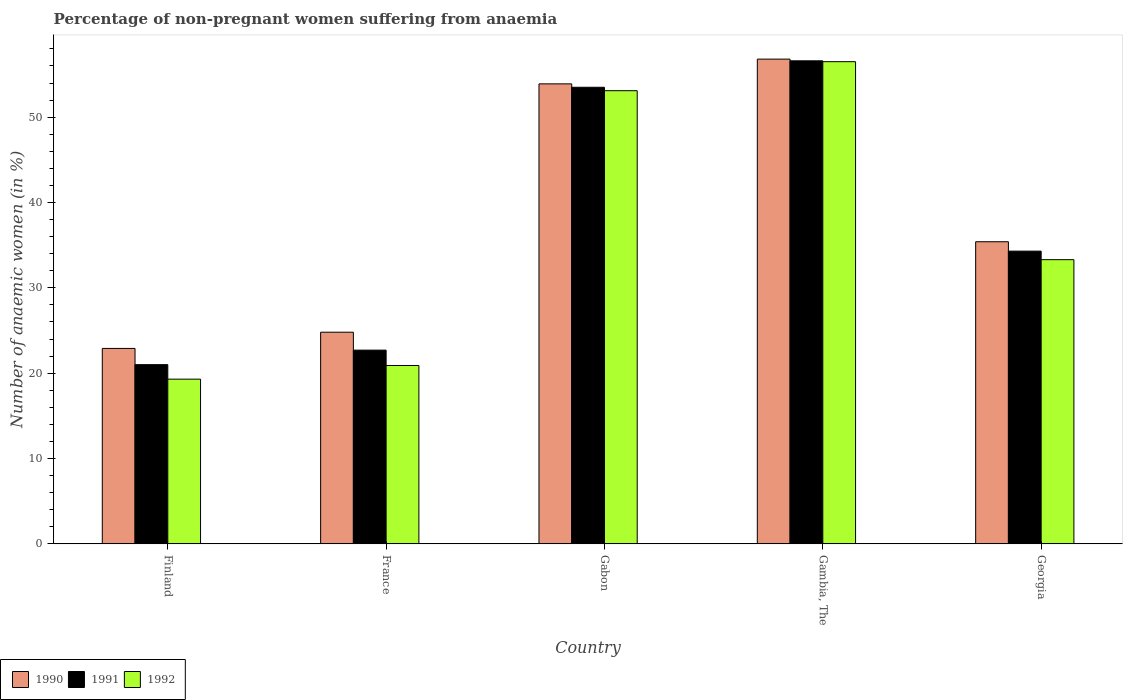How many different coloured bars are there?
Make the answer very short. 3. What is the label of the 3rd group of bars from the left?
Give a very brief answer. Gabon. What is the percentage of non-pregnant women suffering from anaemia in 1991 in Gabon?
Your answer should be compact. 53.5. Across all countries, what is the maximum percentage of non-pregnant women suffering from anaemia in 1990?
Your answer should be very brief. 56.8. Across all countries, what is the minimum percentage of non-pregnant women suffering from anaemia in 1992?
Offer a terse response. 19.3. In which country was the percentage of non-pregnant women suffering from anaemia in 1992 maximum?
Provide a succinct answer. Gambia, The. In which country was the percentage of non-pregnant women suffering from anaemia in 1992 minimum?
Ensure brevity in your answer.  Finland. What is the total percentage of non-pregnant women suffering from anaemia in 1991 in the graph?
Your answer should be very brief. 188.1. What is the difference between the percentage of non-pregnant women suffering from anaemia in 1991 in Finland and that in France?
Provide a succinct answer. -1.7. What is the difference between the percentage of non-pregnant women suffering from anaemia in 1991 in Georgia and the percentage of non-pregnant women suffering from anaemia in 1992 in Gabon?
Offer a terse response. -18.8. What is the average percentage of non-pregnant women suffering from anaemia in 1992 per country?
Provide a short and direct response. 36.62. What is the difference between the percentage of non-pregnant women suffering from anaemia of/in 1990 and percentage of non-pregnant women suffering from anaemia of/in 1992 in Finland?
Offer a terse response. 3.6. In how many countries, is the percentage of non-pregnant women suffering from anaemia in 1992 greater than 12 %?
Give a very brief answer. 5. What is the ratio of the percentage of non-pregnant women suffering from anaemia in 1992 in Finland to that in France?
Your answer should be very brief. 0.92. Is the percentage of non-pregnant women suffering from anaemia in 1992 in France less than that in Georgia?
Your response must be concise. Yes. Is the difference between the percentage of non-pregnant women suffering from anaemia in 1990 in France and Gambia, The greater than the difference between the percentage of non-pregnant women suffering from anaemia in 1992 in France and Gambia, The?
Give a very brief answer. Yes. What is the difference between the highest and the second highest percentage of non-pregnant women suffering from anaemia in 1991?
Provide a succinct answer. 22.3. What is the difference between the highest and the lowest percentage of non-pregnant women suffering from anaemia in 1992?
Your answer should be very brief. 37.2. In how many countries, is the percentage of non-pregnant women suffering from anaemia in 1992 greater than the average percentage of non-pregnant women suffering from anaemia in 1992 taken over all countries?
Ensure brevity in your answer.  2. What does the 3rd bar from the left in France represents?
Offer a very short reply. 1992. What does the 3rd bar from the right in Gambia, The represents?
Your answer should be compact. 1990. How many countries are there in the graph?
Keep it short and to the point. 5. Does the graph contain any zero values?
Provide a short and direct response. No. Where does the legend appear in the graph?
Offer a terse response. Bottom left. What is the title of the graph?
Give a very brief answer. Percentage of non-pregnant women suffering from anaemia. Does "1974" appear as one of the legend labels in the graph?
Make the answer very short. No. What is the label or title of the Y-axis?
Your answer should be very brief. Number of anaemic women (in %). What is the Number of anaemic women (in %) of 1990 in Finland?
Offer a very short reply. 22.9. What is the Number of anaemic women (in %) of 1991 in Finland?
Your answer should be compact. 21. What is the Number of anaemic women (in %) of 1992 in Finland?
Your answer should be very brief. 19.3. What is the Number of anaemic women (in %) in 1990 in France?
Your answer should be compact. 24.8. What is the Number of anaemic women (in %) of 1991 in France?
Provide a short and direct response. 22.7. What is the Number of anaemic women (in %) of 1992 in France?
Your answer should be very brief. 20.9. What is the Number of anaemic women (in %) in 1990 in Gabon?
Provide a short and direct response. 53.9. What is the Number of anaemic women (in %) of 1991 in Gabon?
Make the answer very short. 53.5. What is the Number of anaemic women (in %) in 1992 in Gabon?
Your response must be concise. 53.1. What is the Number of anaemic women (in %) in 1990 in Gambia, The?
Make the answer very short. 56.8. What is the Number of anaemic women (in %) of 1991 in Gambia, The?
Make the answer very short. 56.6. What is the Number of anaemic women (in %) in 1992 in Gambia, The?
Your answer should be very brief. 56.5. What is the Number of anaemic women (in %) of 1990 in Georgia?
Your answer should be very brief. 35.4. What is the Number of anaemic women (in %) in 1991 in Georgia?
Provide a succinct answer. 34.3. What is the Number of anaemic women (in %) in 1992 in Georgia?
Keep it short and to the point. 33.3. Across all countries, what is the maximum Number of anaemic women (in %) in 1990?
Your answer should be compact. 56.8. Across all countries, what is the maximum Number of anaemic women (in %) in 1991?
Make the answer very short. 56.6. Across all countries, what is the maximum Number of anaemic women (in %) in 1992?
Your answer should be compact. 56.5. Across all countries, what is the minimum Number of anaemic women (in %) in 1990?
Make the answer very short. 22.9. Across all countries, what is the minimum Number of anaemic women (in %) of 1991?
Offer a terse response. 21. Across all countries, what is the minimum Number of anaemic women (in %) in 1992?
Your answer should be compact. 19.3. What is the total Number of anaemic women (in %) in 1990 in the graph?
Your answer should be very brief. 193.8. What is the total Number of anaemic women (in %) of 1991 in the graph?
Your answer should be compact. 188.1. What is the total Number of anaemic women (in %) in 1992 in the graph?
Keep it short and to the point. 183.1. What is the difference between the Number of anaemic women (in %) of 1990 in Finland and that in Gabon?
Make the answer very short. -31. What is the difference between the Number of anaemic women (in %) of 1991 in Finland and that in Gabon?
Give a very brief answer. -32.5. What is the difference between the Number of anaemic women (in %) in 1992 in Finland and that in Gabon?
Your answer should be compact. -33.8. What is the difference between the Number of anaemic women (in %) of 1990 in Finland and that in Gambia, The?
Ensure brevity in your answer.  -33.9. What is the difference between the Number of anaemic women (in %) in 1991 in Finland and that in Gambia, The?
Your response must be concise. -35.6. What is the difference between the Number of anaemic women (in %) in 1992 in Finland and that in Gambia, The?
Your answer should be compact. -37.2. What is the difference between the Number of anaemic women (in %) in 1990 in Finland and that in Georgia?
Give a very brief answer. -12.5. What is the difference between the Number of anaemic women (in %) of 1991 in Finland and that in Georgia?
Your answer should be very brief. -13.3. What is the difference between the Number of anaemic women (in %) of 1992 in Finland and that in Georgia?
Make the answer very short. -14. What is the difference between the Number of anaemic women (in %) of 1990 in France and that in Gabon?
Your answer should be very brief. -29.1. What is the difference between the Number of anaemic women (in %) of 1991 in France and that in Gabon?
Ensure brevity in your answer.  -30.8. What is the difference between the Number of anaemic women (in %) in 1992 in France and that in Gabon?
Make the answer very short. -32.2. What is the difference between the Number of anaemic women (in %) of 1990 in France and that in Gambia, The?
Make the answer very short. -32. What is the difference between the Number of anaemic women (in %) of 1991 in France and that in Gambia, The?
Your response must be concise. -33.9. What is the difference between the Number of anaemic women (in %) in 1992 in France and that in Gambia, The?
Offer a very short reply. -35.6. What is the difference between the Number of anaemic women (in %) of 1990 in France and that in Georgia?
Your answer should be compact. -10.6. What is the difference between the Number of anaemic women (in %) in 1992 in France and that in Georgia?
Your answer should be very brief. -12.4. What is the difference between the Number of anaemic women (in %) in 1990 in Gabon and that in Gambia, The?
Make the answer very short. -2.9. What is the difference between the Number of anaemic women (in %) in 1990 in Gabon and that in Georgia?
Keep it short and to the point. 18.5. What is the difference between the Number of anaemic women (in %) of 1991 in Gabon and that in Georgia?
Make the answer very short. 19.2. What is the difference between the Number of anaemic women (in %) in 1992 in Gabon and that in Georgia?
Provide a succinct answer. 19.8. What is the difference between the Number of anaemic women (in %) in 1990 in Gambia, The and that in Georgia?
Offer a very short reply. 21.4. What is the difference between the Number of anaemic women (in %) in 1991 in Gambia, The and that in Georgia?
Your answer should be compact. 22.3. What is the difference between the Number of anaemic women (in %) of 1992 in Gambia, The and that in Georgia?
Offer a terse response. 23.2. What is the difference between the Number of anaemic women (in %) of 1990 in Finland and the Number of anaemic women (in %) of 1991 in France?
Your response must be concise. 0.2. What is the difference between the Number of anaemic women (in %) in 1990 in Finland and the Number of anaemic women (in %) in 1991 in Gabon?
Make the answer very short. -30.6. What is the difference between the Number of anaemic women (in %) of 1990 in Finland and the Number of anaemic women (in %) of 1992 in Gabon?
Offer a very short reply. -30.2. What is the difference between the Number of anaemic women (in %) in 1991 in Finland and the Number of anaemic women (in %) in 1992 in Gabon?
Your response must be concise. -32.1. What is the difference between the Number of anaemic women (in %) of 1990 in Finland and the Number of anaemic women (in %) of 1991 in Gambia, The?
Give a very brief answer. -33.7. What is the difference between the Number of anaemic women (in %) in 1990 in Finland and the Number of anaemic women (in %) in 1992 in Gambia, The?
Offer a very short reply. -33.6. What is the difference between the Number of anaemic women (in %) in 1991 in Finland and the Number of anaemic women (in %) in 1992 in Gambia, The?
Make the answer very short. -35.5. What is the difference between the Number of anaemic women (in %) in 1990 in Finland and the Number of anaemic women (in %) in 1991 in Georgia?
Your response must be concise. -11.4. What is the difference between the Number of anaemic women (in %) of 1990 in Finland and the Number of anaemic women (in %) of 1992 in Georgia?
Your response must be concise. -10.4. What is the difference between the Number of anaemic women (in %) in 1991 in Finland and the Number of anaemic women (in %) in 1992 in Georgia?
Ensure brevity in your answer.  -12.3. What is the difference between the Number of anaemic women (in %) of 1990 in France and the Number of anaemic women (in %) of 1991 in Gabon?
Ensure brevity in your answer.  -28.7. What is the difference between the Number of anaemic women (in %) in 1990 in France and the Number of anaemic women (in %) in 1992 in Gabon?
Give a very brief answer. -28.3. What is the difference between the Number of anaemic women (in %) of 1991 in France and the Number of anaemic women (in %) of 1992 in Gabon?
Ensure brevity in your answer.  -30.4. What is the difference between the Number of anaemic women (in %) in 1990 in France and the Number of anaemic women (in %) in 1991 in Gambia, The?
Provide a succinct answer. -31.8. What is the difference between the Number of anaemic women (in %) of 1990 in France and the Number of anaemic women (in %) of 1992 in Gambia, The?
Ensure brevity in your answer.  -31.7. What is the difference between the Number of anaemic women (in %) of 1991 in France and the Number of anaemic women (in %) of 1992 in Gambia, The?
Offer a terse response. -33.8. What is the difference between the Number of anaemic women (in %) in 1990 in France and the Number of anaemic women (in %) in 1991 in Georgia?
Your answer should be very brief. -9.5. What is the difference between the Number of anaemic women (in %) of 1990 in France and the Number of anaemic women (in %) of 1992 in Georgia?
Your answer should be compact. -8.5. What is the difference between the Number of anaemic women (in %) in 1990 in Gabon and the Number of anaemic women (in %) in 1991 in Gambia, The?
Your answer should be compact. -2.7. What is the difference between the Number of anaemic women (in %) of 1990 in Gabon and the Number of anaemic women (in %) of 1991 in Georgia?
Provide a short and direct response. 19.6. What is the difference between the Number of anaemic women (in %) in 1990 in Gabon and the Number of anaemic women (in %) in 1992 in Georgia?
Your answer should be very brief. 20.6. What is the difference between the Number of anaemic women (in %) of 1991 in Gabon and the Number of anaemic women (in %) of 1992 in Georgia?
Provide a succinct answer. 20.2. What is the difference between the Number of anaemic women (in %) in 1990 in Gambia, The and the Number of anaemic women (in %) in 1991 in Georgia?
Your answer should be compact. 22.5. What is the difference between the Number of anaemic women (in %) of 1991 in Gambia, The and the Number of anaemic women (in %) of 1992 in Georgia?
Your answer should be very brief. 23.3. What is the average Number of anaemic women (in %) of 1990 per country?
Provide a short and direct response. 38.76. What is the average Number of anaemic women (in %) of 1991 per country?
Provide a succinct answer. 37.62. What is the average Number of anaemic women (in %) in 1992 per country?
Your answer should be compact. 36.62. What is the difference between the Number of anaemic women (in %) of 1990 and Number of anaemic women (in %) of 1991 in Finland?
Your answer should be compact. 1.9. What is the difference between the Number of anaemic women (in %) of 1991 and Number of anaemic women (in %) of 1992 in Finland?
Your answer should be very brief. 1.7. What is the difference between the Number of anaemic women (in %) of 1991 and Number of anaemic women (in %) of 1992 in Gabon?
Provide a succinct answer. 0.4. What is the difference between the Number of anaemic women (in %) in 1990 and Number of anaemic women (in %) in 1991 in Gambia, The?
Keep it short and to the point. 0.2. What is the ratio of the Number of anaemic women (in %) of 1990 in Finland to that in France?
Your answer should be very brief. 0.92. What is the ratio of the Number of anaemic women (in %) of 1991 in Finland to that in France?
Your response must be concise. 0.93. What is the ratio of the Number of anaemic women (in %) of 1992 in Finland to that in France?
Ensure brevity in your answer.  0.92. What is the ratio of the Number of anaemic women (in %) of 1990 in Finland to that in Gabon?
Offer a terse response. 0.42. What is the ratio of the Number of anaemic women (in %) in 1991 in Finland to that in Gabon?
Your response must be concise. 0.39. What is the ratio of the Number of anaemic women (in %) in 1992 in Finland to that in Gabon?
Ensure brevity in your answer.  0.36. What is the ratio of the Number of anaemic women (in %) of 1990 in Finland to that in Gambia, The?
Provide a short and direct response. 0.4. What is the ratio of the Number of anaemic women (in %) in 1991 in Finland to that in Gambia, The?
Your response must be concise. 0.37. What is the ratio of the Number of anaemic women (in %) of 1992 in Finland to that in Gambia, The?
Provide a succinct answer. 0.34. What is the ratio of the Number of anaemic women (in %) of 1990 in Finland to that in Georgia?
Provide a succinct answer. 0.65. What is the ratio of the Number of anaemic women (in %) in 1991 in Finland to that in Georgia?
Give a very brief answer. 0.61. What is the ratio of the Number of anaemic women (in %) in 1992 in Finland to that in Georgia?
Offer a very short reply. 0.58. What is the ratio of the Number of anaemic women (in %) in 1990 in France to that in Gabon?
Offer a very short reply. 0.46. What is the ratio of the Number of anaemic women (in %) of 1991 in France to that in Gabon?
Keep it short and to the point. 0.42. What is the ratio of the Number of anaemic women (in %) of 1992 in France to that in Gabon?
Keep it short and to the point. 0.39. What is the ratio of the Number of anaemic women (in %) of 1990 in France to that in Gambia, The?
Ensure brevity in your answer.  0.44. What is the ratio of the Number of anaemic women (in %) of 1991 in France to that in Gambia, The?
Provide a short and direct response. 0.4. What is the ratio of the Number of anaemic women (in %) of 1992 in France to that in Gambia, The?
Provide a short and direct response. 0.37. What is the ratio of the Number of anaemic women (in %) in 1990 in France to that in Georgia?
Give a very brief answer. 0.7. What is the ratio of the Number of anaemic women (in %) of 1991 in France to that in Georgia?
Keep it short and to the point. 0.66. What is the ratio of the Number of anaemic women (in %) of 1992 in France to that in Georgia?
Make the answer very short. 0.63. What is the ratio of the Number of anaemic women (in %) in 1990 in Gabon to that in Gambia, The?
Give a very brief answer. 0.95. What is the ratio of the Number of anaemic women (in %) of 1991 in Gabon to that in Gambia, The?
Provide a succinct answer. 0.95. What is the ratio of the Number of anaemic women (in %) of 1992 in Gabon to that in Gambia, The?
Provide a short and direct response. 0.94. What is the ratio of the Number of anaemic women (in %) in 1990 in Gabon to that in Georgia?
Ensure brevity in your answer.  1.52. What is the ratio of the Number of anaemic women (in %) of 1991 in Gabon to that in Georgia?
Offer a terse response. 1.56. What is the ratio of the Number of anaemic women (in %) of 1992 in Gabon to that in Georgia?
Keep it short and to the point. 1.59. What is the ratio of the Number of anaemic women (in %) in 1990 in Gambia, The to that in Georgia?
Offer a terse response. 1.6. What is the ratio of the Number of anaemic women (in %) of 1991 in Gambia, The to that in Georgia?
Your response must be concise. 1.65. What is the ratio of the Number of anaemic women (in %) in 1992 in Gambia, The to that in Georgia?
Offer a terse response. 1.7. What is the difference between the highest and the second highest Number of anaemic women (in %) of 1990?
Offer a very short reply. 2.9. What is the difference between the highest and the second highest Number of anaemic women (in %) in 1991?
Provide a succinct answer. 3.1. What is the difference between the highest and the second highest Number of anaemic women (in %) in 1992?
Give a very brief answer. 3.4. What is the difference between the highest and the lowest Number of anaemic women (in %) in 1990?
Make the answer very short. 33.9. What is the difference between the highest and the lowest Number of anaemic women (in %) in 1991?
Your answer should be compact. 35.6. What is the difference between the highest and the lowest Number of anaemic women (in %) of 1992?
Provide a succinct answer. 37.2. 